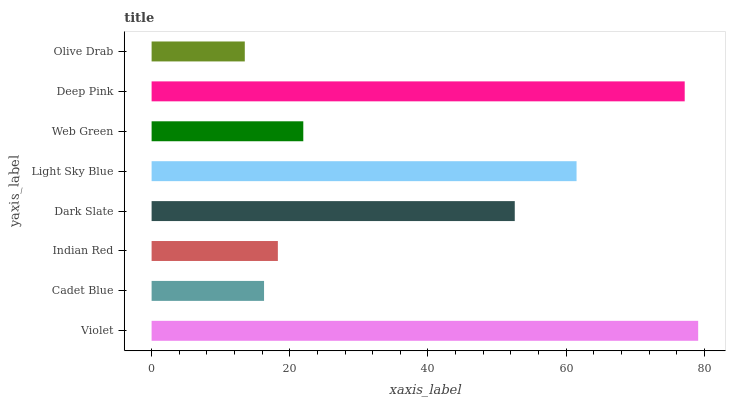Is Olive Drab the minimum?
Answer yes or no. Yes. Is Violet the maximum?
Answer yes or no. Yes. Is Cadet Blue the minimum?
Answer yes or no. No. Is Cadet Blue the maximum?
Answer yes or no. No. Is Violet greater than Cadet Blue?
Answer yes or no. Yes. Is Cadet Blue less than Violet?
Answer yes or no. Yes. Is Cadet Blue greater than Violet?
Answer yes or no. No. Is Violet less than Cadet Blue?
Answer yes or no. No. Is Dark Slate the high median?
Answer yes or no. Yes. Is Web Green the low median?
Answer yes or no. Yes. Is Light Sky Blue the high median?
Answer yes or no. No. Is Light Sky Blue the low median?
Answer yes or no. No. 